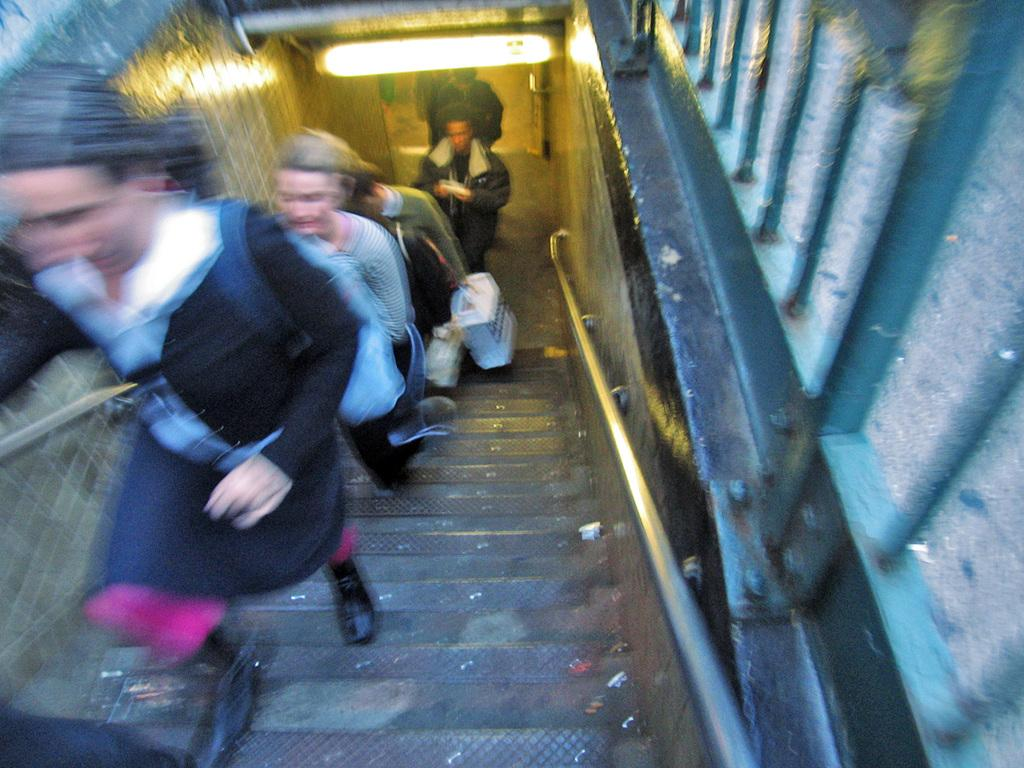What is happening in the image involving a group of people? The people in the image are walking on the steps. What can be seen in the background of the image? There is a wall and a light in the background of the image. How many eyes can be seen on the girl in the image? There is no girl present in the image, and therefore no eyes can be seen. What type of horn is visible on the wall in the image? There is no horn present on the wall or in the image. 